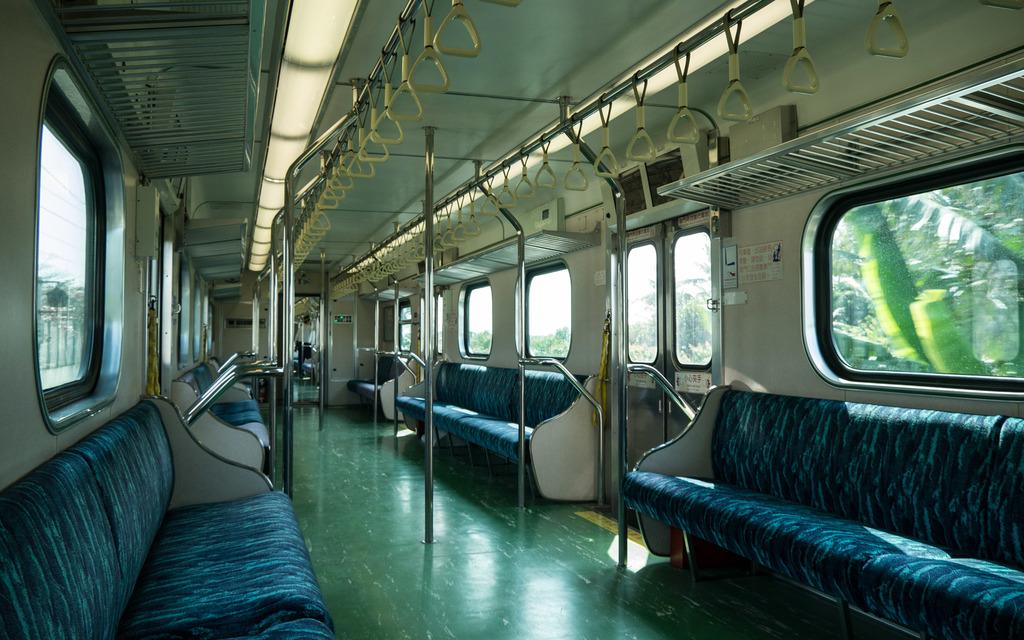What type of vehicle is shown in the image? The image shows the interior view of a train. What specific features can be seen inside the train? There are grills, doors, rods, seats, handles, and windows visible in the train. What can be seen outside the train through the windows? Trees, sky, and electric poles are visible in the background of the image. Can you see any toys on the seats in the image? There are no toys visible on the seats in the image. Who is giving a kiss to the person sitting next to them in the image? There is no indication of any kissing or affectionate behavior in the image. 